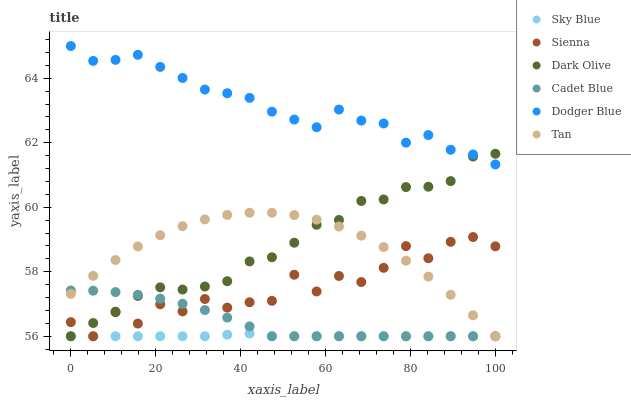Does Sky Blue have the minimum area under the curve?
Answer yes or no. Yes. Does Dodger Blue have the maximum area under the curve?
Answer yes or no. Yes. Does Dark Olive have the minimum area under the curve?
Answer yes or no. No. Does Dark Olive have the maximum area under the curve?
Answer yes or no. No. Is Sky Blue the smoothest?
Answer yes or no. Yes. Is Sienna the roughest?
Answer yes or no. Yes. Is Dark Olive the smoothest?
Answer yes or no. No. Is Dark Olive the roughest?
Answer yes or no. No. Does Cadet Blue have the lowest value?
Answer yes or no. Yes. Does Dodger Blue have the lowest value?
Answer yes or no. No. Does Dodger Blue have the highest value?
Answer yes or no. Yes. Does Dark Olive have the highest value?
Answer yes or no. No. Is Tan less than Dodger Blue?
Answer yes or no. Yes. Is Dodger Blue greater than Tan?
Answer yes or no. Yes. Does Sky Blue intersect Dark Olive?
Answer yes or no. Yes. Is Sky Blue less than Dark Olive?
Answer yes or no. No. Is Sky Blue greater than Dark Olive?
Answer yes or no. No. Does Tan intersect Dodger Blue?
Answer yes or no. No. 